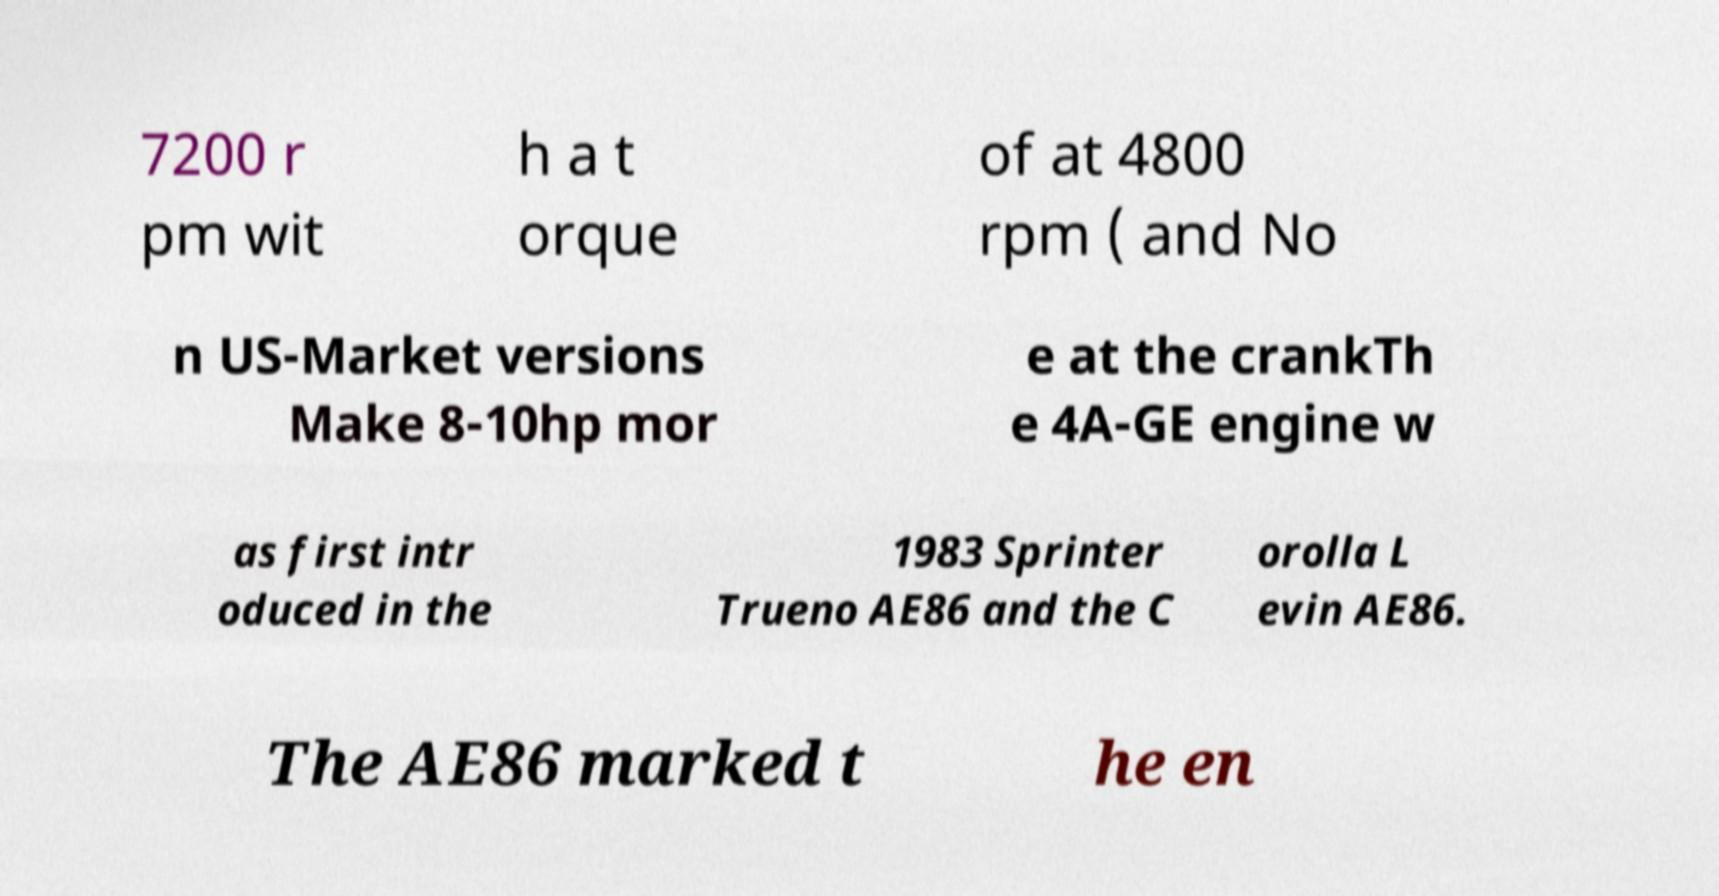Please identify and transcribe the text found in this image. 7200 r pm wit h a t orque of at 4800 rpm ( and No n US-Market versions Make 8-10hp mor e at the crankTh e 4A-GE engine w as first intr oduced in the 1983 Sprinter Trueno AE86 and the C orolla L evin AE86. The AE86 marked t he en 